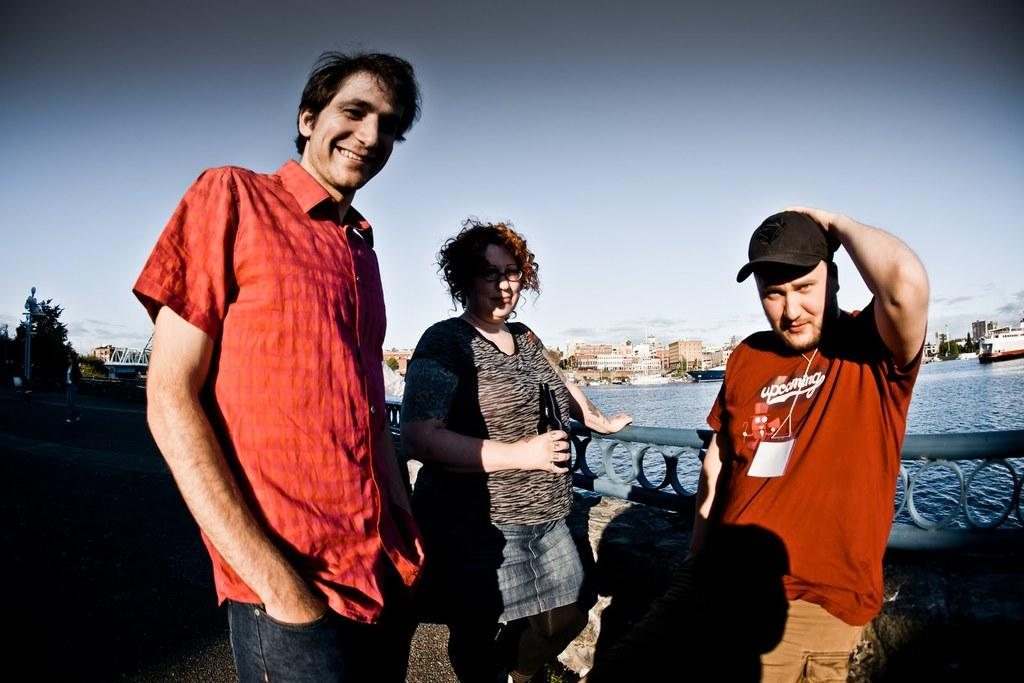How many people are present in the image? There are 3 people standing in the image. What is the facial expression of the people in the image? The people are smiling. What can be seen in the background of the image? There are trees, buildings, boats on the water, and the sky visible in the background of the image. What is the weight of the mice in the image? There are no mice present in the image, so their weight cannot be determined. 